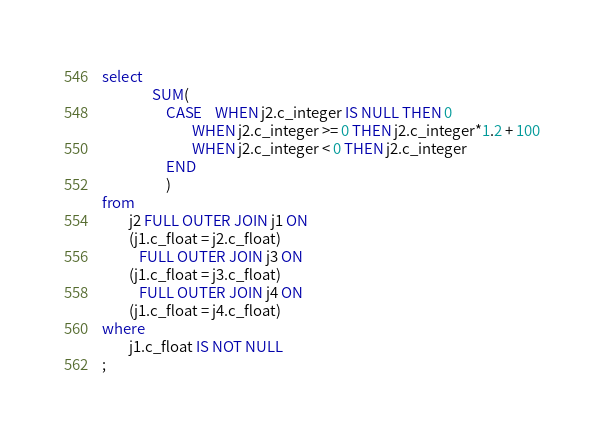<code> <loc_0><loc_0><loc_500><loc_500><_SQL_>select
               SUM(
                   CASE    WHEN j2.c_integer IS NULL THEN 0
                           WHEN j2.c_integer >= 0 THEN j2.c_integer*1.2 + 100
                           WHEN j2.c_integer < 0 THEN j2.c_integer
                   END
                   )
from
        j2 FULL OUTER JOIN j1 ON
        (j1.c_float = j2.c_float)
           FULL OUTER JOIN j3 ON
        (j1.c_float = j3.c_float)
           FULL OUTER JOIN j4 ON
        (j1.c_float = j4.c_float)
where
        j1.c_float IS NOT NULL
;
</code> 